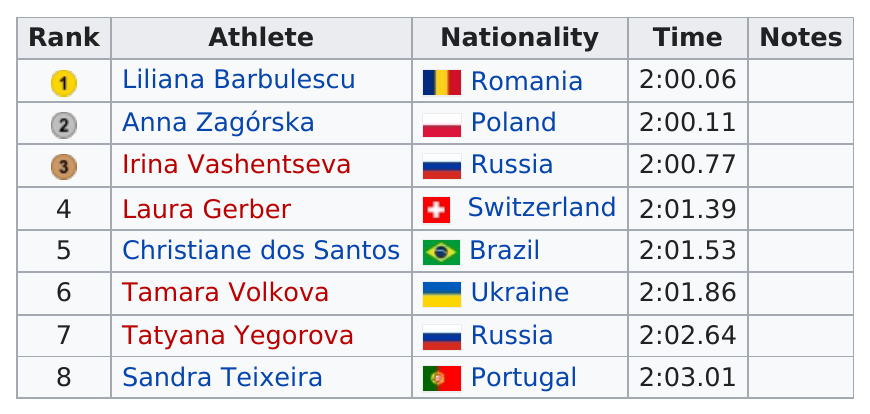Identify some key points in this picture. Brazil is the south American country that follows Irina Vashentseva. The seventh runner's previous time was 2:02.64, and the last runner finished the race in 2:03.01. Russia had the most finishers in the top 8. There are two Russian participants in this set of semifinals. Anna Zagorska received second place with a time of 2:00.11. 